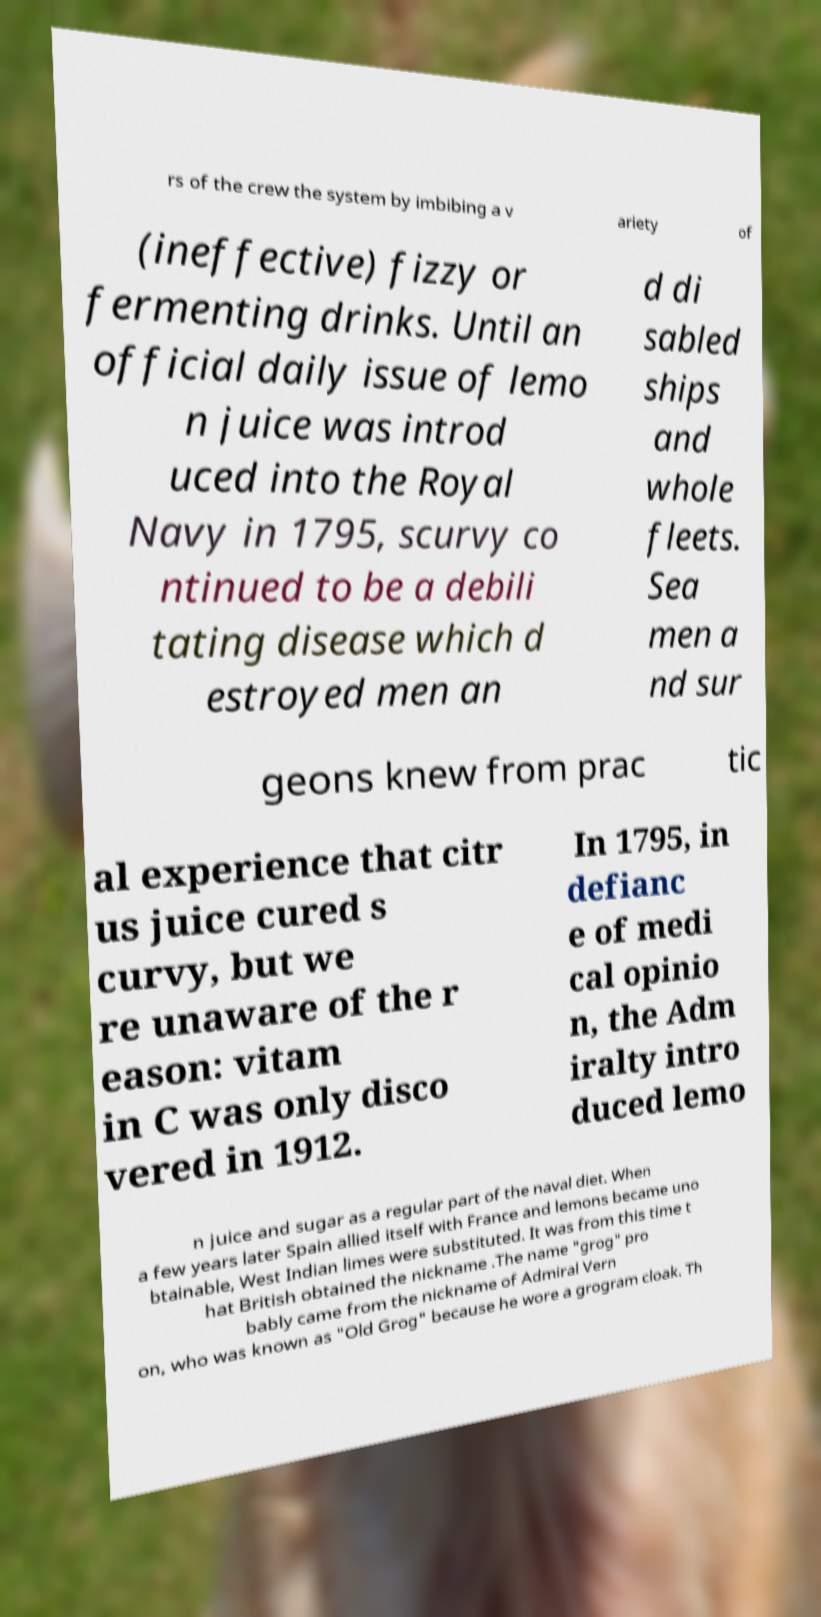Please read and relay the text visible in this image. What does it say? rs of the crew the system by imbibing a v ariety of (ineffective) fizzy or fermenting drinks. Until an official daily issue of lemo n juice was introd uced into the Royal Navy in 1795, scurvy co ntinued to be a debili tating disease which d estroyed men an d di sabled ships and whole fleets. Sea men a nd sur geons knew from prac tic al experience that citr us juice cured s curvy, but we re unaware of the r eason: vitam in C was only disco vered in 1912. In 1795, in defianc e of medi cal opinio n, the Adm iralty intro duced lemo n juice and sugar as a regular part of the naval diet. When a few years later Spain allied itself with France and lemons became uno btainable, West Indian limes were substituted. It was from this time t hat British obtained the nickname .The name "grog" pro bably came from the nickname of Admiral Vern on, who was known as "Old Grog" because he wore a grogram cloak. Th 